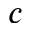<formula> <loc_0><loc_0><loc_500><loc_500>c</formula> 